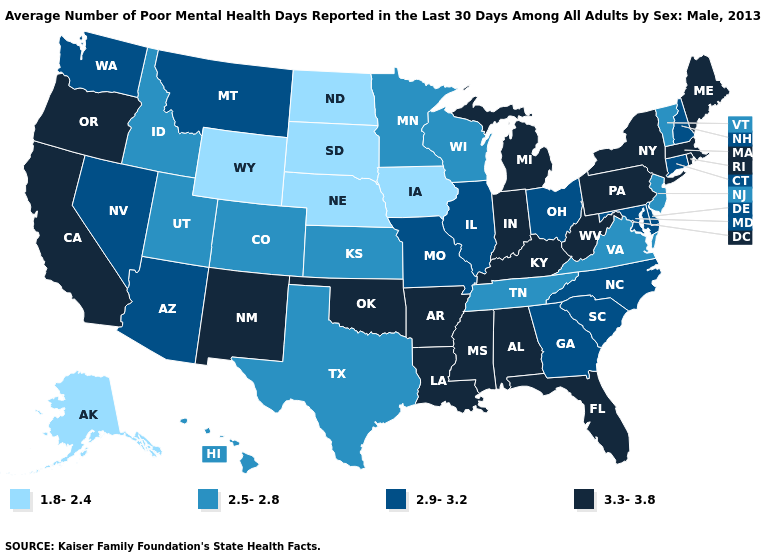Name the states that have a value in the range 2.9-3.2?
Be succinct. Arizona, Connecticut, Delaware, Georgia, Illinois, Maryland, Missouri, Montana, Nevada, New Hampshire, North Carolina, Ohio, South Carolina, Washington. Does the map have missing data?
Answer briefly. No. Name the states that have a value in the range 3.3-3.8?
Keep it brief. Alabama, Arkansas, California, Florida, Indiana, Kentucky, Louisiana, Maine, Massachusetts, Michigan, Mississippi, New Mexico, New York, Oklahoma, Oregon, Pennsylvania, Rhode Island, West Virginia. Name the states that have a value in the range 2.5-2.8?
Short answer required. Colorado, Hawaii, Idaho, Kansas, Minnesota, New Jersey, Tennessee, Texas, Utah, Vermont, Virginia, Wisconsin. Does the map have missing data?
Concise answer only. No. What is the lowest value in the USA?
Give a very brief answer. 1.8-2.4. What is the value of New Mexico?
Answer briefly. 3.3-3.8. Name the states that have a value in the range 3.3-3.8?
Give a very brief answer. Alabama, Arkansas, California, Florida, Indiana, Kentucky, Louisiana, Maine, Massachusetts, Michigan, Mississippi, New Mexico, New York, Oklahoma, Oregon, Pennsylvania, Rhode Island, West Virginia. Does Nebraska have the lowest value in the USA?
Give a very brief answer. Yes. Name the states that have a value in the range 1.8-2.4?
Quick response, please. Alaska, Iowa, Nebraska, North Dakota, South Dakota, Wyoming. Does Nevada have the same value as Kentucky?
Keep it brief. No. What is the value of Pennsylvania?
Concise answer only. 3.3-3.8. Among the states that border Indiana , which have the lowest value?
Give a very brief answer. Illinois, Ohio. Name the states that have a value in the range 1.8-2.4?
Short answer required. Alaska, Iowa, Nebraska, North Dakota, South Dakota, Wyoming. Among the states that border New Hampshire , does Maine have the lowest value?
Concise answer only. No. 